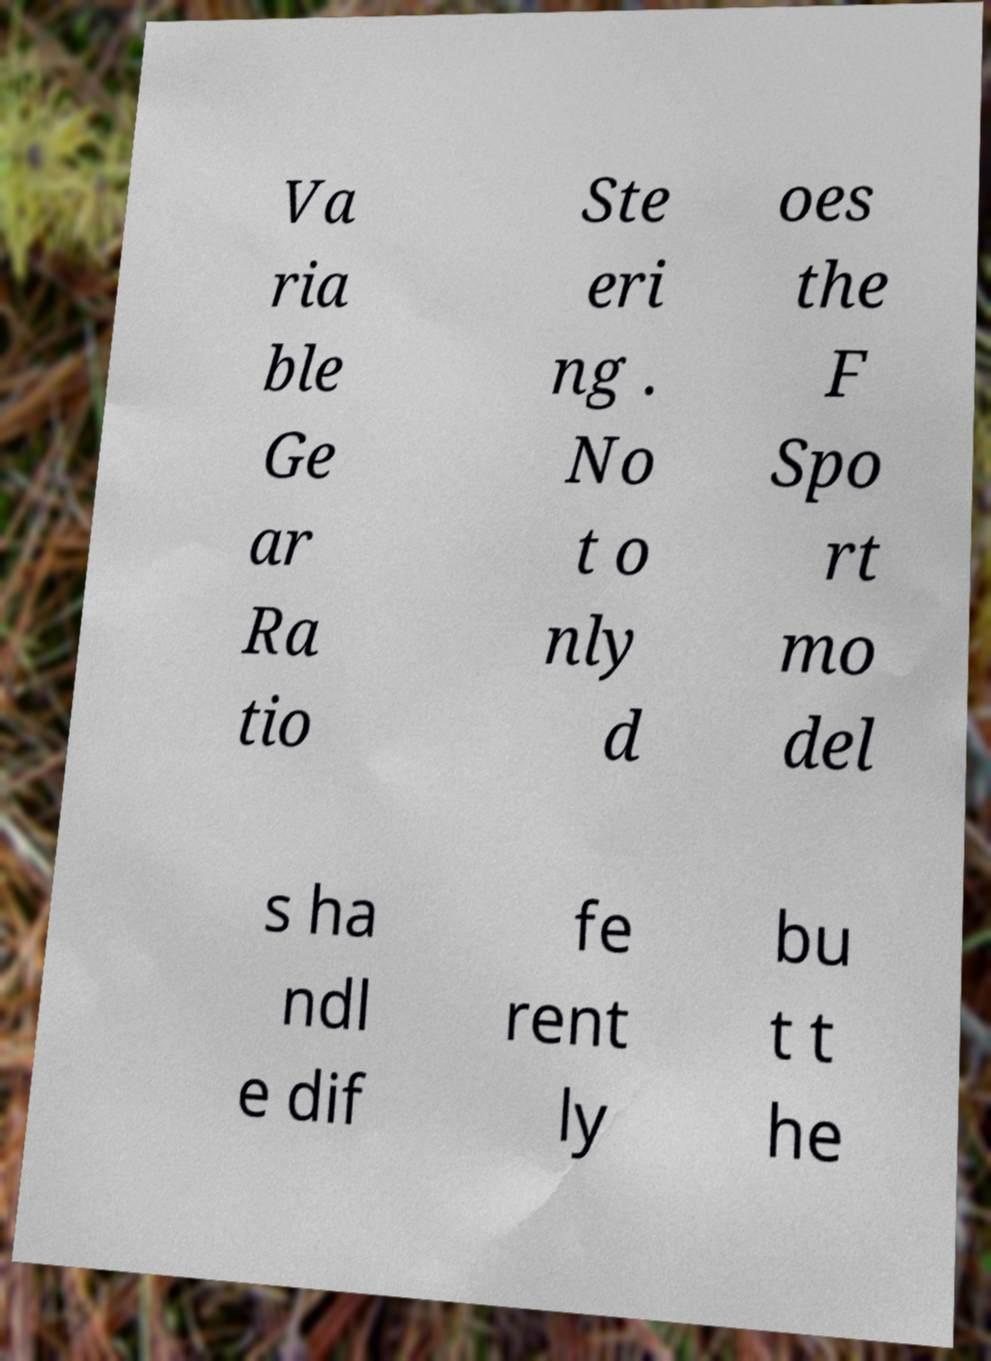I need the written content from this picture converted into text. Can you do that? Va ria ble Ge ar Ra tio Ste eri ng . No t o nly d oes the F Spo rt mo del s ha ndl e dif fe rent ly bu t t he 